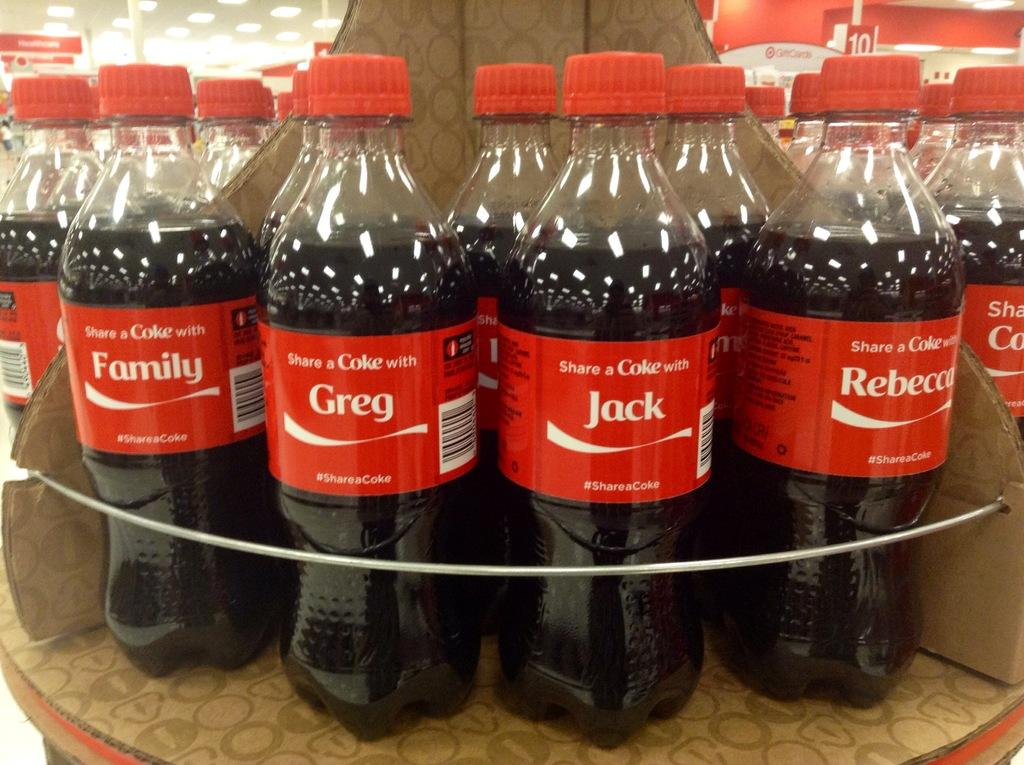<image>
Provide a brief description of the given image. A shopping display shelf with an assortment of Coke bottles with peoples names on them. 